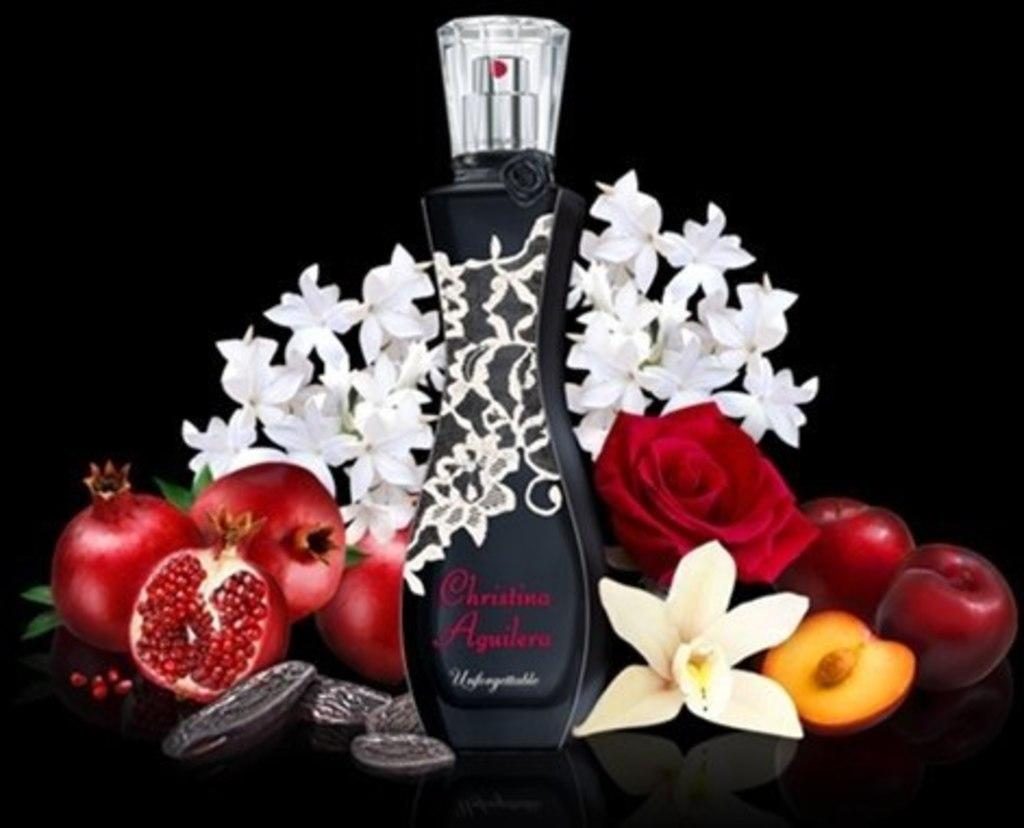Provide a one-sentence caption for the provided image. A bottle of Christina Aguilera perfume surrounded by fruits and flowers. 